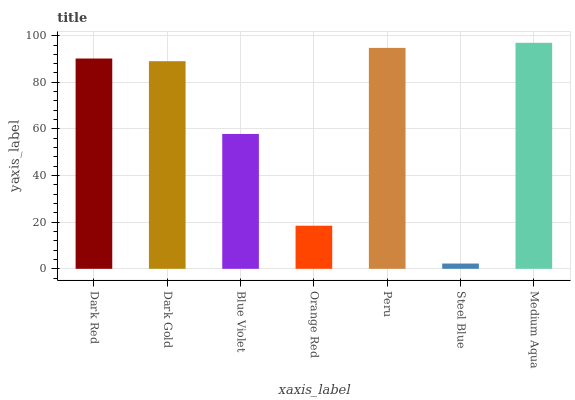Is Dark Gold the minimum?
Answer yes or no. No. Is Dark Gold the maximum?
Answer yes or no. No. Is Dark Red greater than Dark Gold?
Answer yes or no. Yes. Is Dark Gold less than Dark Red?
Answer yes or no. Yes. Is Dark Gold greater than Dark Red?
Answer yes or no. No. Is Dark Red less than Dark Gold?
Answer yes or no. No. Is Dark Gold the high median?
Answer yes or no. Yes. Is Dark Gold the low median?
Answer yes or no. Yes. Is Steel Blue the high median?
Answer yes or no. No. Is Orange Red the low median?
Answer yes or no. No. 